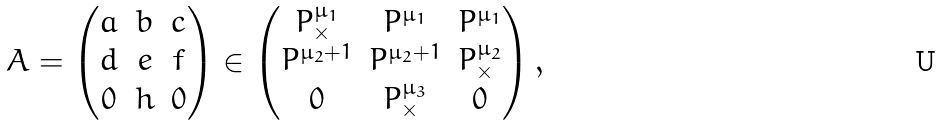Convert formula to latex. <formula><loc_0><loc_0><loc_500><loc_500>A = \begin{pmatrix} a & b & c \\ d & e & f \\ 0 & h & 0 \end{pmatrix} \in \begin{pmatrix} P ^ { \mu _ { 1 } } _ { \times } & P ^ { \mu _ { 1 } } & P ^ { \mu _ { 1 } } \\ P ^ { \mu _ { 2 } + 1 } & P ^ { \mu _ { 2 } + 1 } & P ^ { \mu _ { 2 } } _ { \times } \\ 0 & P ^ { \mu _ { 3 } } _ { \times } & 0 \end{pmatrix} ,</formula> 